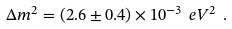Convert formula to latex. <formula><loc_0><loc_0><loc_500><loc_500>\Delta m ^ { 2 } = ( 2 . 6 \pm 0 . 4 ) \times 1 0 ^ { - 3 } \ e V ^ { 2 } \ .</formula> 